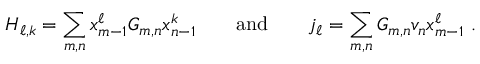<formula> <loc_0><loc_0><loc_500><loc_500>H _ { \ell , k } = \sum _ { m , n } x _ { m - 1 } ^ { \ell } G _ { m , n } x _ { n - 1 } ^ { k } \quad a n d \quad j _ { \ell } = \sum _ { m , n } G _ { m , n } v _ { n } x _ { m - 1 } ^ { \ell } \ .</formula> 